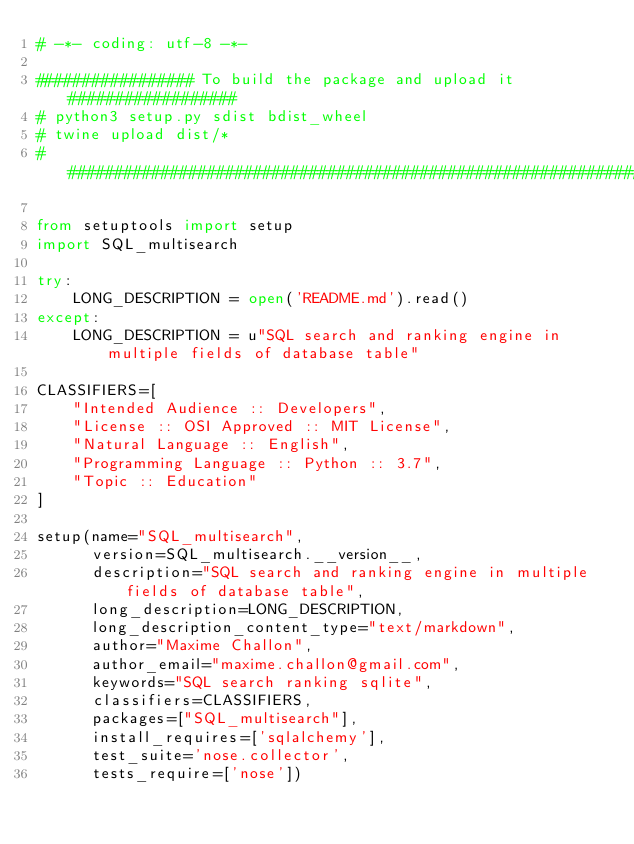Convert code to text. <code><loc_0><loc_0><loc_500><loc_500><_Python_># -*- coding: utf-8 -*-

################# To build the package and upload it ##################
# python3 setup.py sdist bdist_wheel
# twine upload dist/*
#######################################################################

from setuptools import setup
import SQL_multisearch

try:
    LONG_DESCRIPTION = open('README.md').read()
except:
    LONG_DESCRIPTION = u"SQL search and ranking engine in multiple fields of database table"

CLASSIFIERS=[
    "Intended Audience :: Developers",
    "License :: OSI Approved :: MIT License",
    "Natural Language :: English",
    "Programming Language :: Python :: 3.7",
    "Topic :: Education"
]

setup(name="SQL_multisearch",
      version=SQL_multisearch.__version__,
      description="SQL search and ranking engine in multiple fields of database table",
      long_description=LONG_DESCRIPTION,
      long_description_content_type="text/markdown",
      author="Maxime Challon",
      author_email="maxime.challon@gmail.com",
      keywords="SQL search ranking sqlite",
      classifiers=CLASSIFIERS,
      packages=["SQL_multisearch"],
      install_requires=['sqlalchemy'],
      test_suite='nose.collector',
      tests_require=['nose'])</code> 